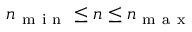<formula> <loc_0><loc_0><loc_500><loc_500>n _ { m i n } \leq n \leq n _ { m a x }</formula> 